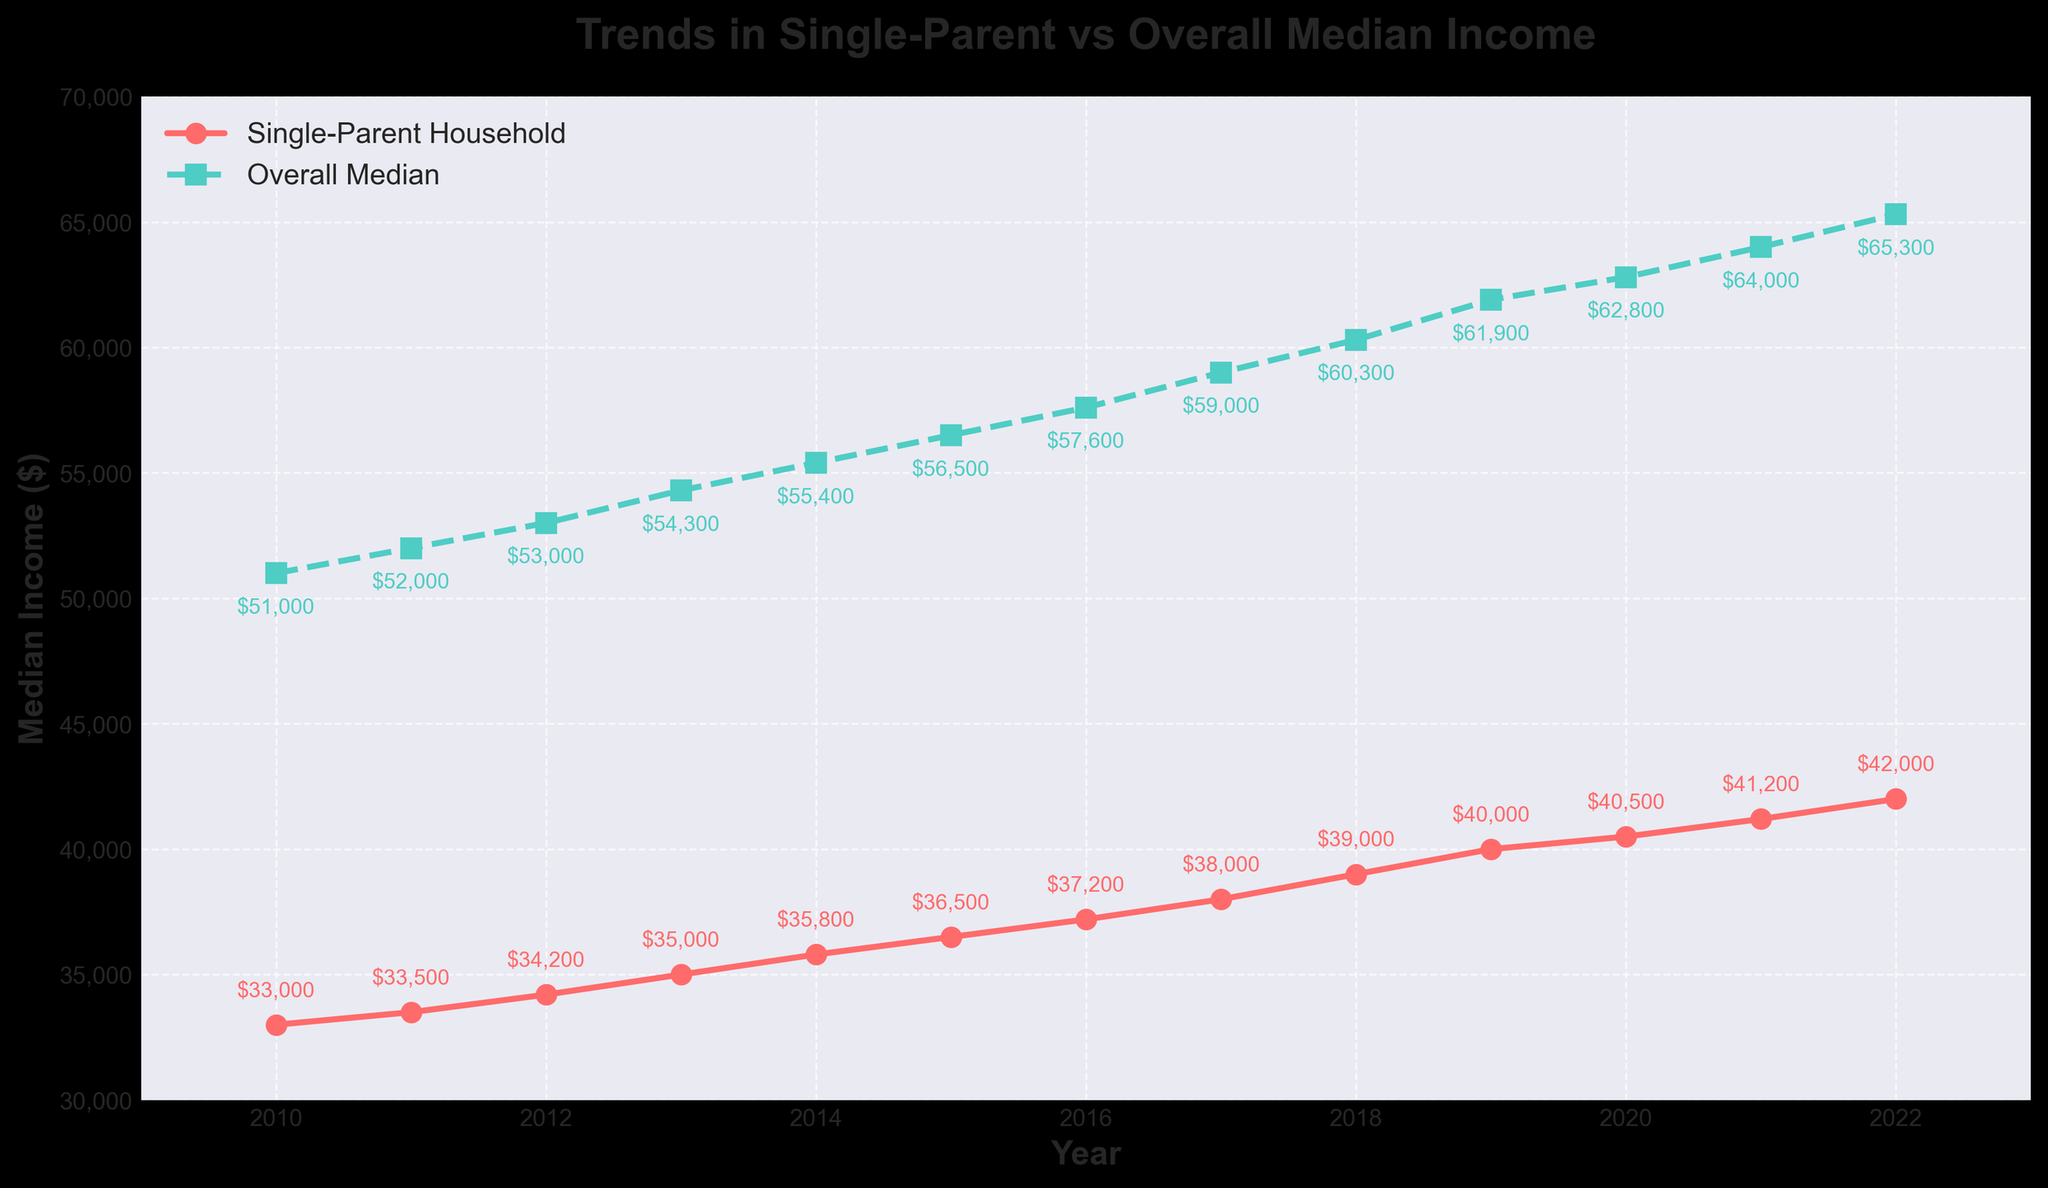What is the trend in the single-parent household median income from 2010 to 2022? To determine the trend, observe the red line plotting single-parent household median income from 2010 to 2022. The line shows a consistent upward movement.
Answer: Upward trend In which year was the single-parent household median income the highest? Look at the highest point of the red line. The year corresponding to this point is the highest median income for single-parent households. The highest point is in 2022.
Answer: 2022 How much was the difference between single-parent household median income and overall median income in 2010? Subtract the single-parent household median income in 2010 from the overall median income in 2010. The difference is $51,000 - $33,000 = $18,000.
Answer: $18,000 By how much did the single-parent household median income increase from 2010 to 2022? Subtract the single-parent household median income in 2010 from the value in 2022. The increase is $42,000 - $33,000 = $9,000.
Answer: $9,000 What is the overall trend in median income for both single-parent households and the overall population? Observing both the red line (single-parent household) and the green dashed line (overall median), both lines show a consistent increase over time from 2010 to 2022.
Answer: Both are upward trends Compare the rate of increase in median income for single-parent households and the overall population from 2010 to 2022. Calculate the percentage increase for both. For single-parent households: (($42,000 - $33,000) / $33,000) * 100 ≈ 27.27%. For overall median income: (($65,300 - $51,000) / $51,000) * 100 ≈ 28.63%. The overall population had a slightly higher rate of increase.
Answer: Overall population had a higher rate In what year did the overall median income exceed $60,000? Look at the green dashed line to identify the earliest year it crosses the $60,000 mark. This occurs in 2018.
Answer: 2018 Which visual elements are used to distinguish the single-parent household median income from the overall median income? The single-parent household income is represented with a solid red line and circle markers, while the overall median income is depicted with a dashed green line and square markers.
Answer: Red line with circles and green dashed line with squares How does the gap between single-parent median income and overall median income change over the years? Observe the vertical distance between the red and green lines. The gap widens slightly over time, indicating the income difference increases.
Answer: Increases Which line has fewer data point annotations and what do they represent? Both lines have annotations for each year, but the annotations on the green dashed line represent the overall median income, and those on the red line indicate the single-parent household median income.
Answer: Both have annotations, one for overall and one for single-parent income 